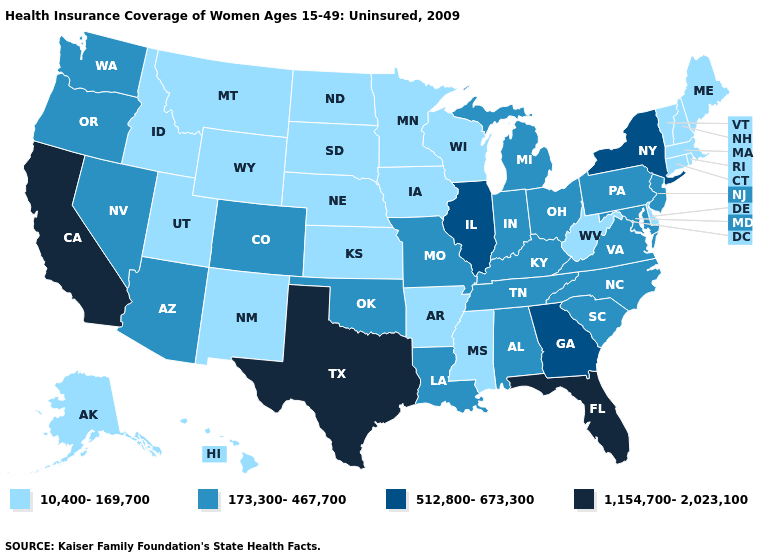Among the states that border Virginia , does West Virginia have the lowest value?
Write a very short answer. Yes. Among the states that border Minnesota , which have the highest value?
Quick response, please. Iowa, North Dakota, South Dakota, Wisconsin. Which states have the highest value in the USA?
Short answer required. California, Florida, Texas. Does the first symbol in the legend represent the smallest category?
Write a very short answer. Yes. Does Louisiana have the same value as Kansas?
Be succinct. No. Name the states that have a value in the range 1,154,700-2,023,100?
Write a very short answer. California, Florida, Texas. Name the states that have a value in the range 1,154,700-2,023,100?
Concise answer only. California, Florida, Texas. What is the value of Vermont?
Keep it brief. 10,400-169,700. What is the value of Washington?
Concise answer only. 173,300-467,700. Does Florida have the highest value in the USA?
Short answer required. Yes. Does the first symbol in the legend represent the smallest category?
Short answer required. Yes. Which states have the lowest value in the MidWest?
Quick response, please. Iowa, Kansas, Minnesota, Nebraska, North Dakota, South Dakota, Wisconsin. What is the highest value in states that border Kansas?
Give a very brief answer. 173,300-467,700. What is the lowest value in states that border Iowa?
Answer briefly. 10,400-169,700. Which states have the lowest value in the West?
Be succinct. Alaska, Hawaii, Idaho, Montana, New Mexico, Utah, Wyoming. 